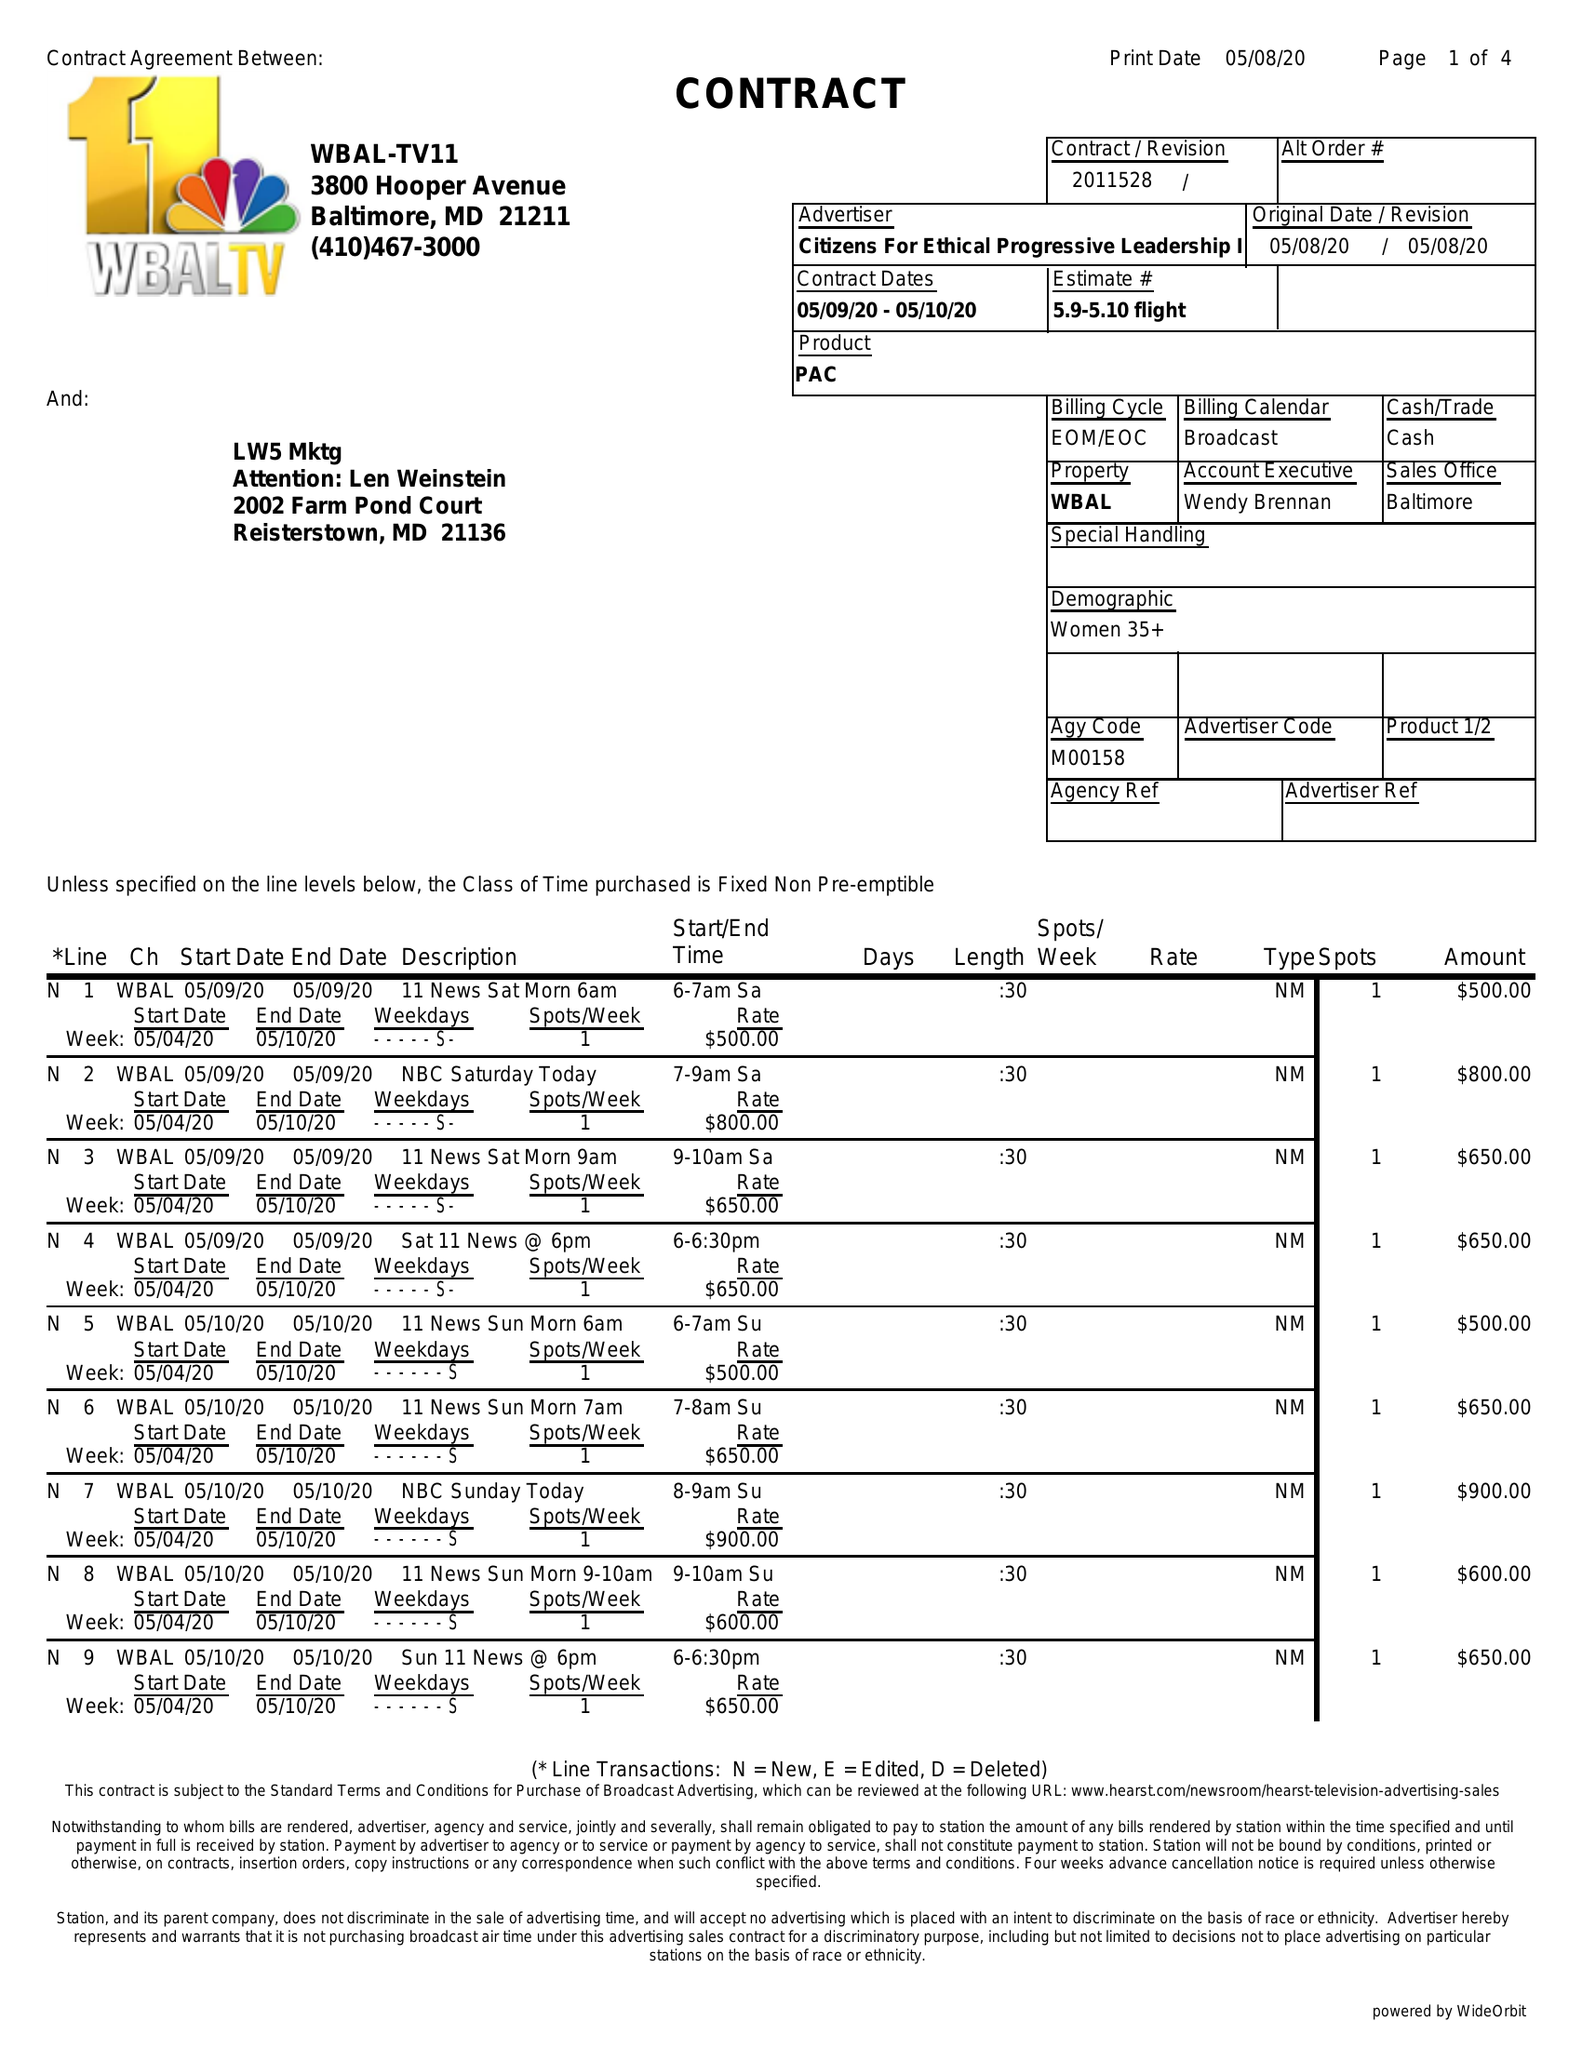What is the value for the gross_amount?
Answer the question using a single word or phrase. 5900.00 